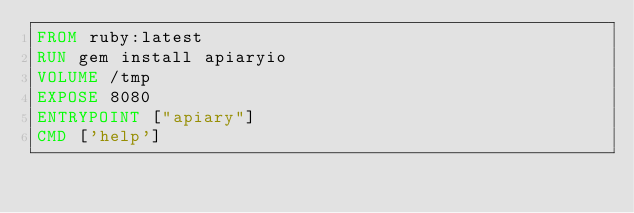Convert code to text. <code><loc_0><loc_0><loc_500><loc_500><_Dockerfile_>FROM ruby:latest
RUN gem install apiaryio
VOLUME /tmp
EXPOSE 8080
ENTRYPOINT ["apiary"]
CMD ['help']
</code> 